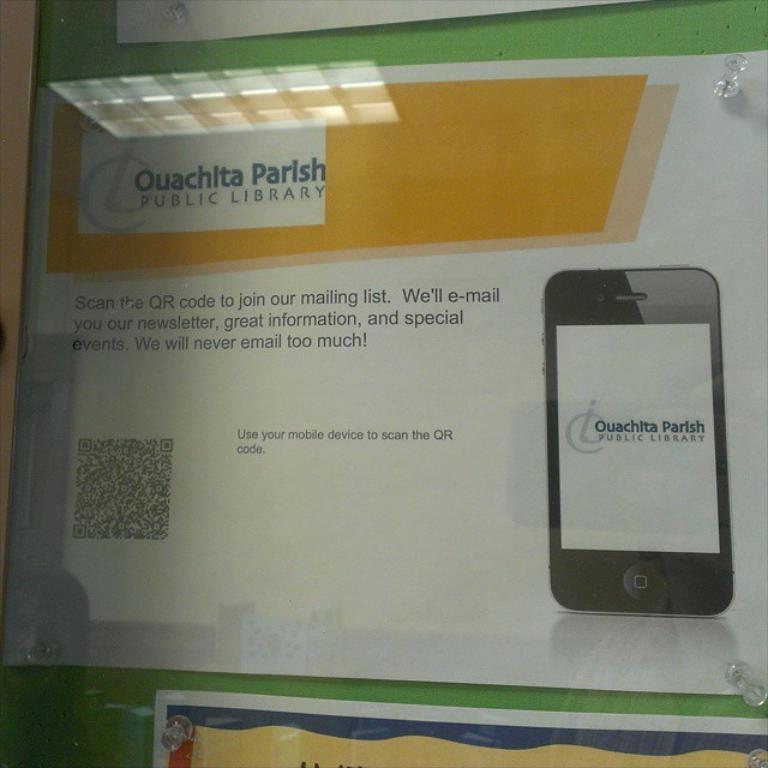<image>
Render a clear and concise summary of the photo. an ad for the Ouachita Parish Public Library saying to scan a QR code 